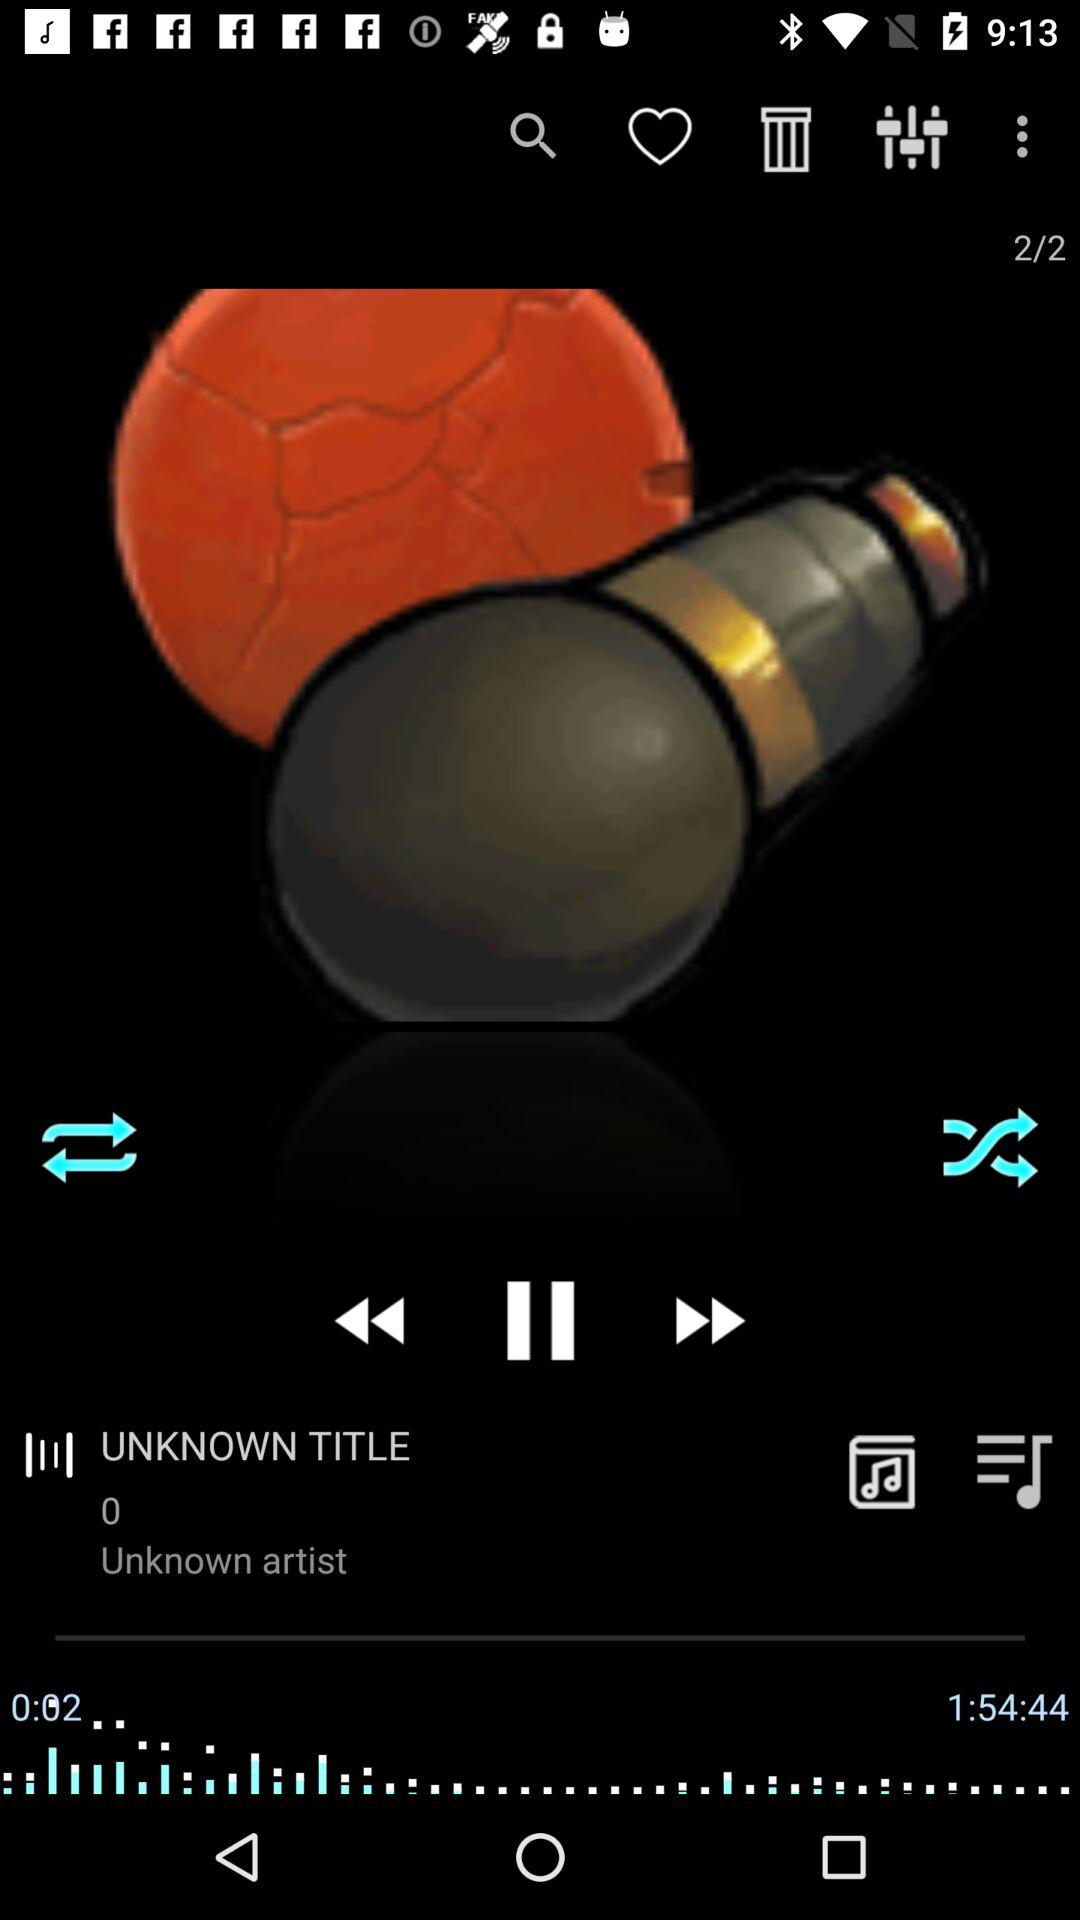What is the total duration of the track? The total duration of the track is 1 hour 54 minutes 44 seconds. 